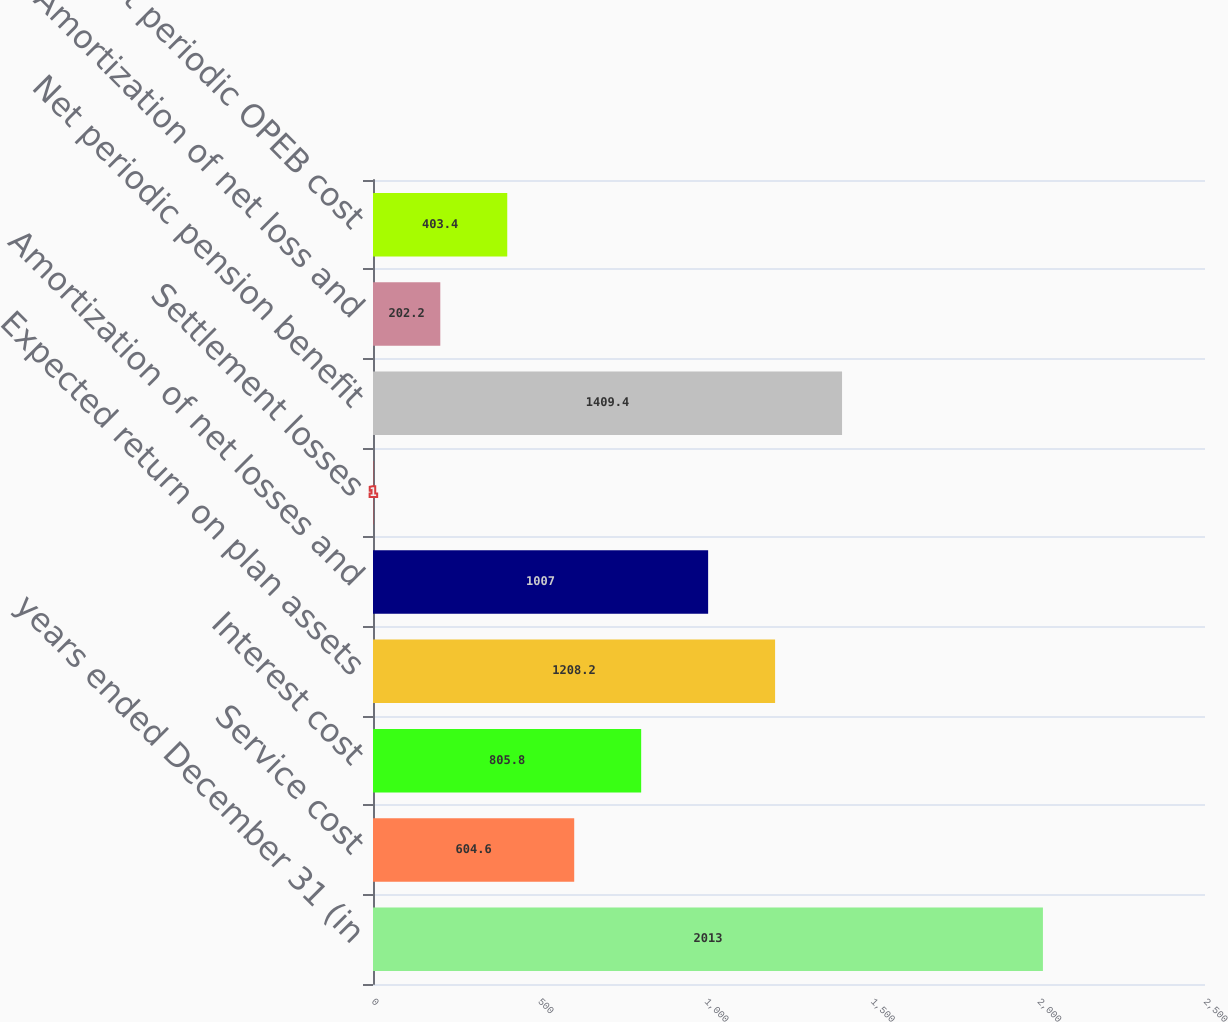<chart> <loc_0><loc_0><loc_500><loc_500><bar_chart><fcel>years ended December 31 (in<fcel>Service cost<fcel>Interest cost<fcel>Expected return on plan assets<fcel>Amortization of net losses and<fcel>Settlement losses<fcel>Net periodic pension benefit<fcel>Amortization of net loss and<fcel>Net periodic OPEB cost<nl><fcel>2013<fcel>604.6<fcel>805.8<fcel>1208.2<fcel>1007<fcel>1<fcel>1409.4<fcel>202.2<fcel>403.4<nl></chart> 